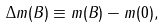Convert formula to latex. <formula><loc_0><loc_0><loc_500><loc_500>\Delta m ( B ) \equiv m ( B ) - m ( 0 ) ,</formula> 